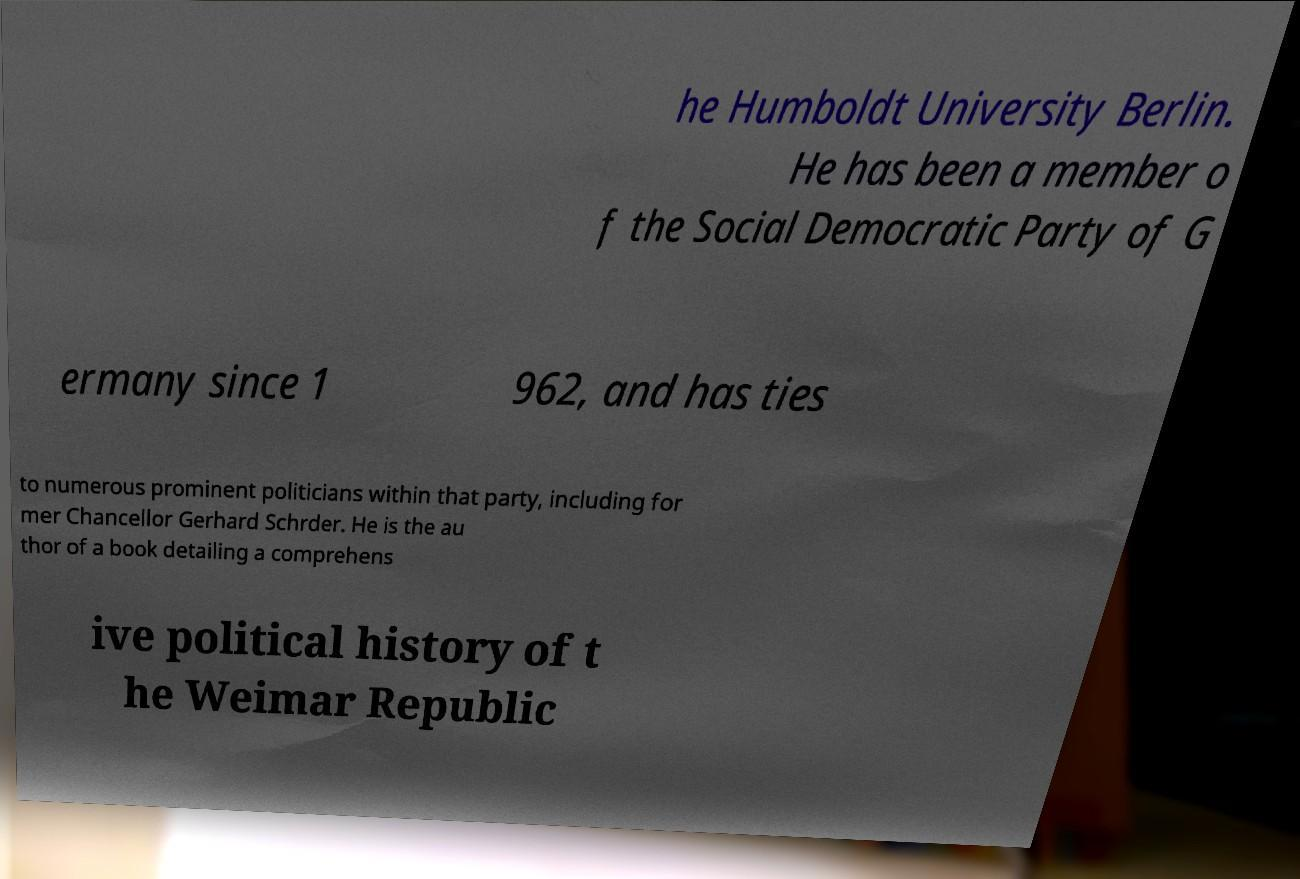Please read and relay the text visible in this image. What does it say? he Humboldt University Berlin. He has been a member o f the Social Democratic Party of G ermany since 1 962, and has ties to numerous prominent politicians within that party, including for mer Chancellor Gerhard Schrder. He is the au thor of a book detailing a comprehens ive political history of t he Weimar Republic 